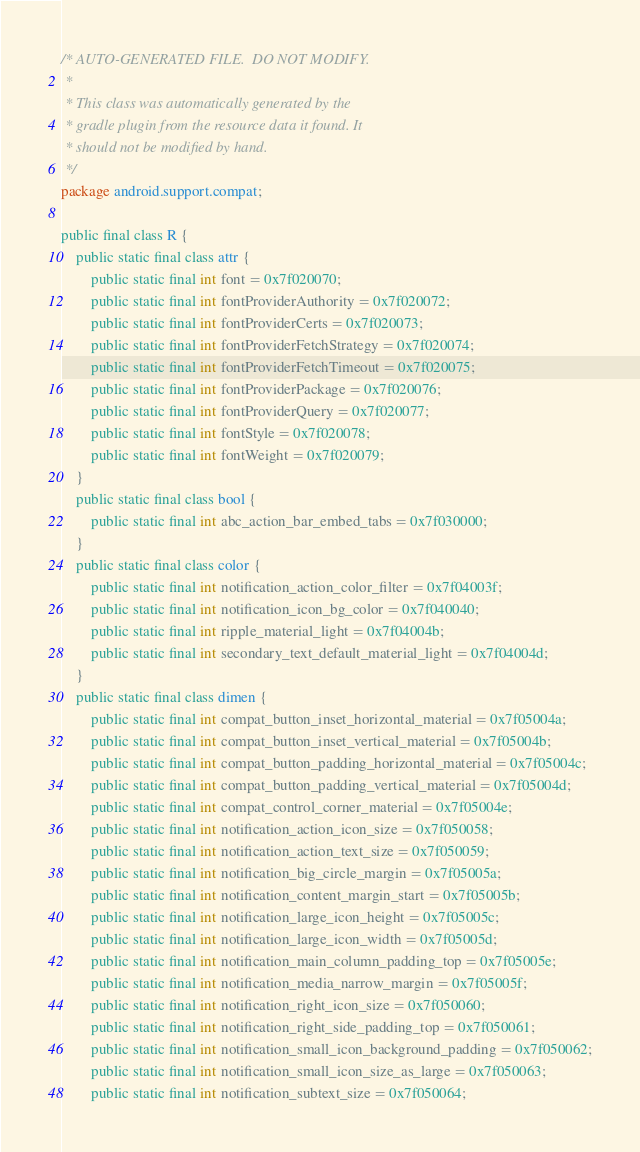<code> <loc_0><loc_0><loc_500><loc_500><_Java_>/* AUTO-GENERATED FILE.  DO NOT MODIFY.
 *
 * This class was automatically generated by the
 * gradle plugin from the resource data it found. It
 * should not be modified by hand.
 */
package android.support.compat;

public final class R {
    public static final class attr {
        public static final int font = 0x7f020070;
        public static final int fontProviderAuthority = 0x7f020072;
        public static final int fontProviderCerts = 0x7f020073;
        public static final int fontProviderFetchStrategy = 0x7f020074;
        public static final int fontProviderFetchTimeout = 0x7f020075;
        public static final int fontProviderPackage = 0x7f020076;
        public static final int fontProviderQuery = 0x7f020077;
        public static final int fontStyle = 0x7f020078;
        public static final int fontWeight = 0x7f020079;
    }
    public static final class bool {
        public static final int abc_action_bar_embed_tabs = 0x7f030000;
    }
    public static final class color {
        public static final int notification_action_color_filter = 0x7f04003f;
        public static final int notification_icon_bg_color = 0x7f040040;
        public static final int ripple_material_light = 0x7f04004b;
        public static final int secondary_text_default_material_light = 0x7f04004d;
    }
    public static final class dimen {
        public static final int compat_button_inset_horizontal_material = 0x7f05004a;
        public static final int compat_button_inset_vertical_material = 0x7f05004b;
        public static final int compat_button_padding_horizontal_material = 0x7f05004c;
        public static final int compat_button_padding_vertical_material = 0x7f05004d;
        public static final int compat_control_corner_material = 0x7f05004e;
        public static final int notification_action_icon_size = 0x7f050058;
        public static final int notification_action_text_size = 0x7f050059;
        public static final int notification_big_circle_margin = 0x7f05005a;
        public static final int notification_content_margin_start = 0x7f05005b;
        public static final int notification_large_icon_height = 0x7f05005c;
        public static final int notification_large_icon_width = 0x7f05005d;
        public static final int notification_main_column_padding_top = 0x7f05005e;
        public static final int notification_media_narrow_margin = 0x7f05005f;
        public static final int notification_right_icon_size = 0x7f050060;
        public static final int notification_right_side_padding_top = 0x7f050061;
        public static final int notification_small_icon_background_padding = 0x7f050062;
        public static final int notification_small_icon_size_as_large = 0x7f050063;
        public static final int notification_subtext_size = 0x7f050064;</code> 